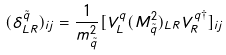<formula> <loc_0><loc_0><loc_500><loc_500>( \delta _ { L R } ^ { \tilde { q } } ) _ { i j } = \frac { 1 } { m _ { \tilde { q } } ^ { 2 } } [ V _ { L } ^ { q } ( M _ { \tilde { q } } ^ { 2 } ) _ { L R } V _ { R } ^ { q \dagger } ] _ { i j }</formula> 